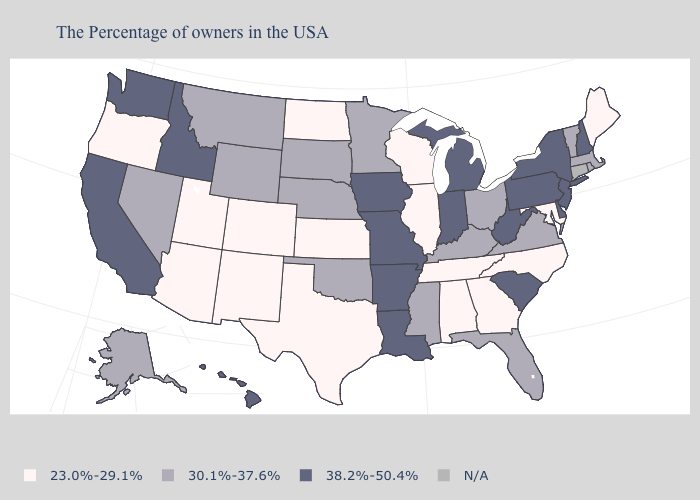Name the states that have a value in the range N/A?
Be succinct. Connecticut. What is the lowest value in the USA?
Answer briefly. 23.0%-29.1%. Which states have the highest value in the USA?
Give a very brief answer. New Hampshire, New York, New Jersey, Delaware, Pennsylvania, South Carolina, West Virginia, Michigan, Indiana, Louisiana, Missouri, Arkansas, Iowa, Idaho, California, Washington, Hawaii. What is the value of Vermont?
Short answer required. 30.1%-37.6%. Which states have the lowest value in the USA?
Short answer required. Maine, Maryland, North Carolina, Georgia, Alabama, Tennessee, Wisconsin, Illinois, Kansas, Texas, North Dakota, Colorado, New Mexico, Utah, Arizona, Oregon. What is the highest value in the MidWest ?
Short answer required. 38.2%-50.4%. What is the value of North Dakota?
Quick response, please. 23.0%-29.1%. Is the legend a continuous bar?
Answer briefly. No. Does the first symbol in the legend represent the smallest category?
Short answer required. Yes. What is the value of Mississippi?
Write a very short answer. 30.1%-37.6%. Does North Dakota have the lowest value in the MidWest?
Quick response, please. Yes. Which states have the highest value in the USA?
Concise answer only. New Hampshire, New York, New Jersey, Delaware, Pennsylvania, South Carolina, West Virginia, Michigan, Indiana, Louisiana, Missouri, Arkansas, Iowa, Idaho, California, Washington, Hawaii. Does Utah have the highest value in the USA?
Quick response, please. No. 